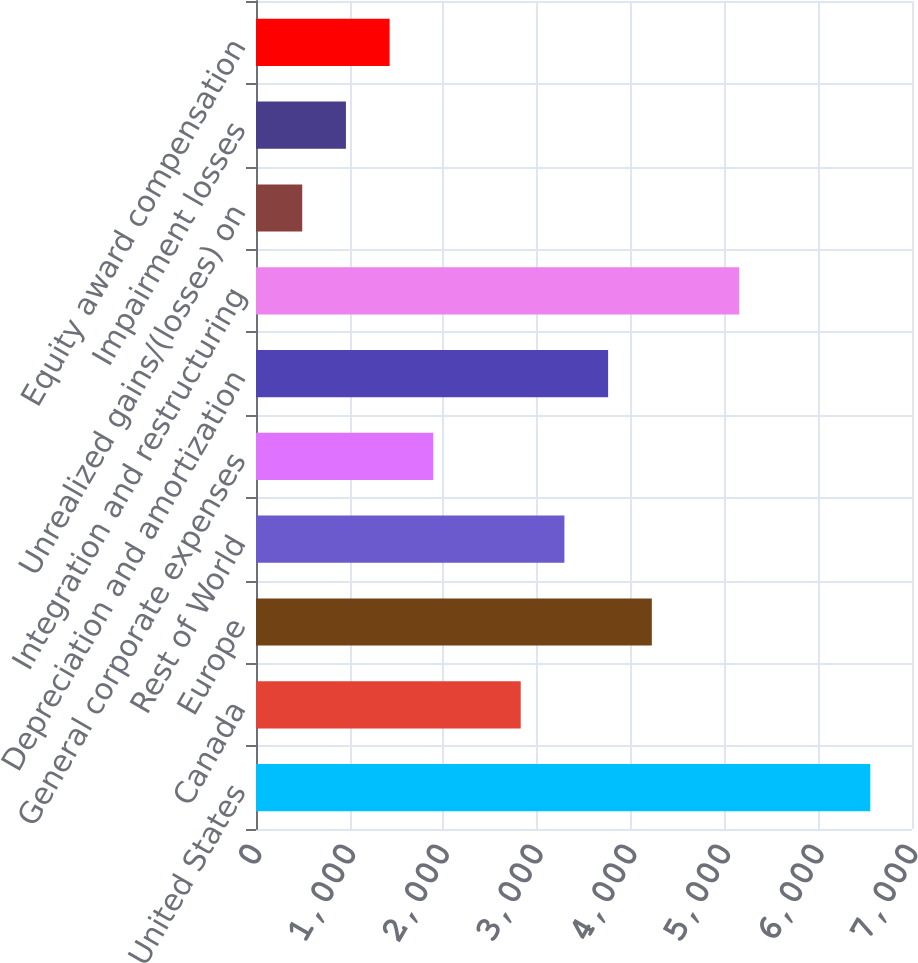Convert chart. <chart><loc_0><loc_0><loc_500><loc_500><bar_chart><fcel>United States<fcel>Canada<fcel>Europe<fcel>Rest of World<fcel>General corporate expenses<fcel>Depreciation and amortization<fcel>Integration and restructuring<fcel>Unrealized gains/(losses) on<fcel>Impairment losses<fcel>Equity award compensation<nl><fcel>6555.2<fcel>2824.8<fcel>4223.7<fcel>3291.1<fcel>1892.2<fcel>3757.4<fcel>5156.3<fcel>493.3<fcel>959.6<fcel>1425.9<nl></chart> 